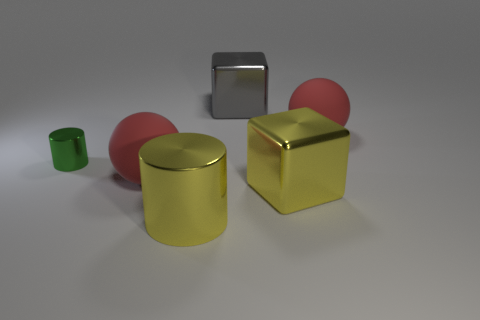Subtract all blue balls. Subtract all brown cylinders. How many balls are left? 2 Subtract all purple blocks. How many gray spheres are left? 0 Add 1 small reds. How many grays exist? 0 Subtract all red rubber objects. Subtract all metal things. How many objects are left? 0 Add 2 yellow cylinders. How many yellow cylinders are left? 3 Add 4 gray cylinders. How many gray cylinders exist? 4 Add 2 cyan shiny things. How many objects exist? 8 Subtract all yellow cubes. How many cubes are left? 1 Subtract 2 red balls. How many objects are left? 4 Subtract all cylinders. How many objects are left? 4 